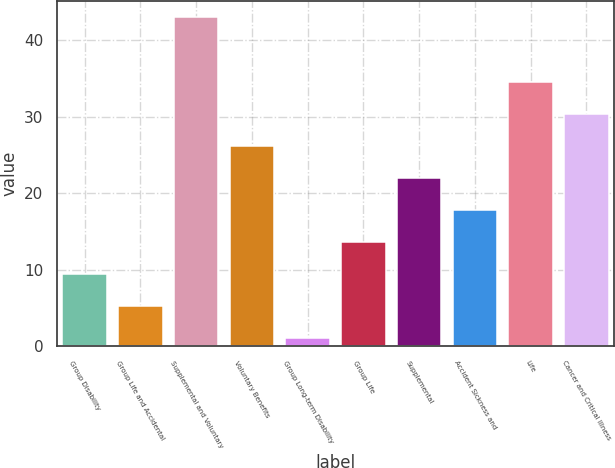Convert chart to OTSL. <chart><loc_0><loc_0><loc_500><loc_500><bar_chart><fcel>Group Disability<fcel>Group Life and Accidental<fcel>Supplemental and Voluntary<fcel>Voluntary Benefits<fcel>Group Long-term Disability<fcel>Group Life<fcel>Supplemental<fcel>Accident Sickness and<fcel>Life<fcel>Cancer and Critical Illness<nl><fcel>9.52<fcel>5.34<fcel>43<fcel>26.24<fcel>1.16<fcel>13.7<fcel>22.06<fcel>17.88<fcel>34.6<fcel>30.42<nl></chart> 